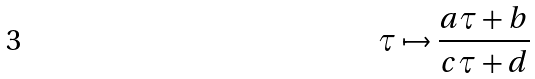<formula> <loc_0><loc_0><loc_500><loc_500>\tau \mapsto \frac { a \tau + b } { c \tau + d }</formula> 